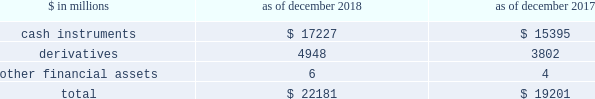The goldman sachs group , inc .
And subsidiaries notes to consolidated financial statements the table below presents a summary of level 3 financial assets. .
Level 3 financial assets as of december 2018 increased compared with december 2017 , primarily reflecting an increase in level 3 cash instruments .
See notes 6 through 8 for further information about level 3 financial assets ( including information about unrealized gains and losses related to level 3 financial assets and financial liabilities , and transfers in and out of level 3 ) .
Note 6 .
Cash instruments cash instruments include u.s .
Government and agency obligations , non-u.s .
Government and agency obligations , mortgage-backed loans and securities , corporate debt instruments , equity securities , investments in funds at nav , and other non-derivative financial instruments owned and financial instruments sold , but not yet purchased .
See below for the types of cash instruments included in each level of the fair value hierarchy and the valuation techniques and significant inputs used to determine their fair values .
See note 5 for an overview of the firm 2019s fair value measurement policies .
Level 1 cash instruments level 1 cash instruments include certain money market instruments , u.s .
Government obligations , most non-u.s .
Government obligations , certain government agency obligations , certain corporate debt instruments and actively traded listed equities .
These instruments are valued using quoted prices for identical unrestricted instruments in active markets .
The firm defines active markets for equity instruments based on the average daily trading volume both in absolute terms and relative to the market capitalization for the instrument .
The firm defines active markets for debt instruments based on both the average daily trading volume and the number of days with trading activity .
Level 2 cash instruments level 2 cash instruments include most money market instruments , most government agency obligations , certain non-u.s .
Government obligations , most mortgage-backed loans and securities , most corporate debt instruments , most state and municipal obligations , most other debt obligations , restricted or less liquid listed equities , commodities and certain lending commitments .
Valuations of level 2 cash instruments can be verified to quoted prices , recent trading activity for identical or similar instruments , broker or dealer quotations or alternative pricing sources with reasonable levels of price transparency .
Consideration is given to the nature of the quotations ( e.g. , indicative or firm ) and the relationship of recent market activity to the prices provided from alternative pricing sources .
Valuation adjustments are typically made to level 2 cash instruments ( i ) if the cash instrument is subject to transfer restrictions and/or ( ii ) for other premiums and liquidity discounts that a market participant would require to arrive at fair value .
Valuation adjustments are generally based on market evidence .
Level 3 cash instruments level 3 cash instruments have one or more significant valuation inputs that are not observable .
Absent evidence to the contrary , level 3 cash instruments are initially valued at transaction price , which is considered to be the best initial estimate of fair value .
Subsequently , the firm uses other methodologies to determine fair value , which vary based on the type of instrument .
Valuation inputs and assumptions are changed when corroborated by substantive observable evidence , including values realized on sales .
Valuation techniques and significant inputs of level 3 cash instruments valuation techniques of level 3 cash instruments vary by instrument , but are generally based on discounted cash flow techniques .
The valuation techniques and the nature of significant inputs used to determine the fair values of each type of level 3 cash instrument are described below : loans and securities backed by commercial real estate .
Loans and securities backed by commercial real estate are directly or indirectly collateralized by a single commercial real estate property or a portfolio of properties , and may include tranches of varying levels of subordination .
Significant inputs are generally determined based on relative value analyses and include : 2030 market yields implied by transactions of similar or related assets and/or current levels and changes in market indices such as the cmbx ( an index that tracks the performance of commercial mortgage bonds ) ; 118 goldman sachs 2018 form 10-k .
What is the percentage change in total financial assets from 2017 to 2018? 
Computations: ((22181 - 19201) / 19201)
Answer: 0.1552. 